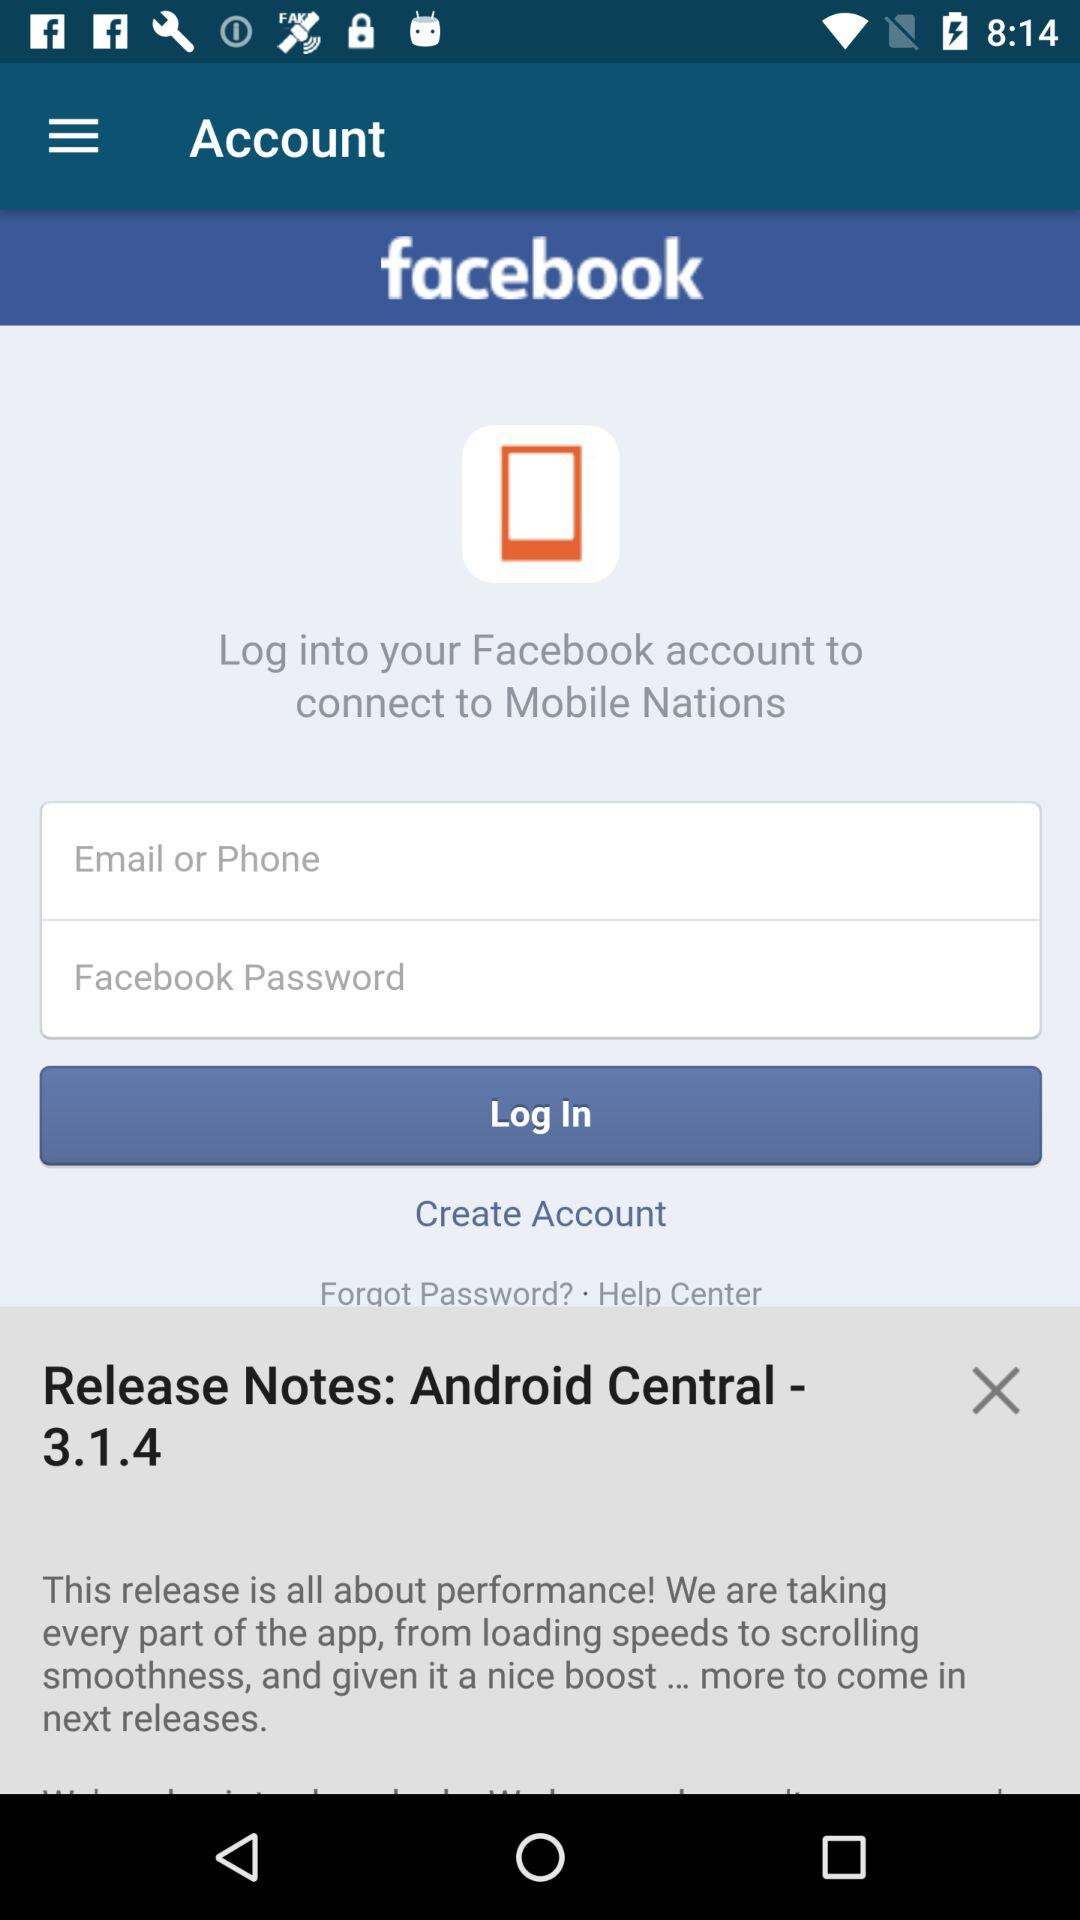What are the requirements to get a login? The requirements are "Email or Phone" and "Facebook Password". 